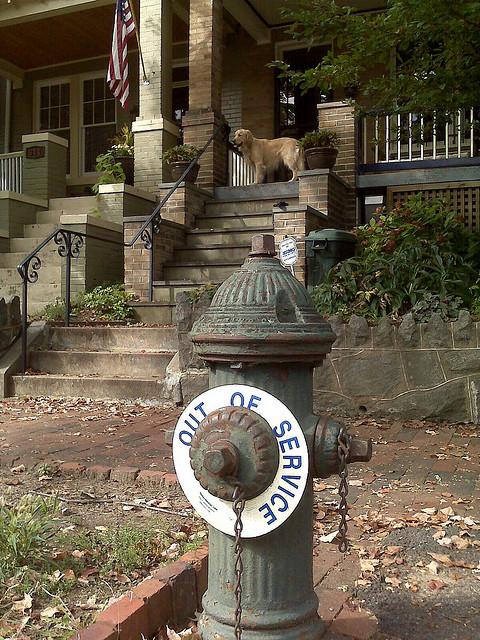Does the fire hydrant work?
Write a very short answer. No. Does the house have an alarm system?
Concise answer only. Yes. What is in the picture?
Concise answer only. Fire hydrant. 